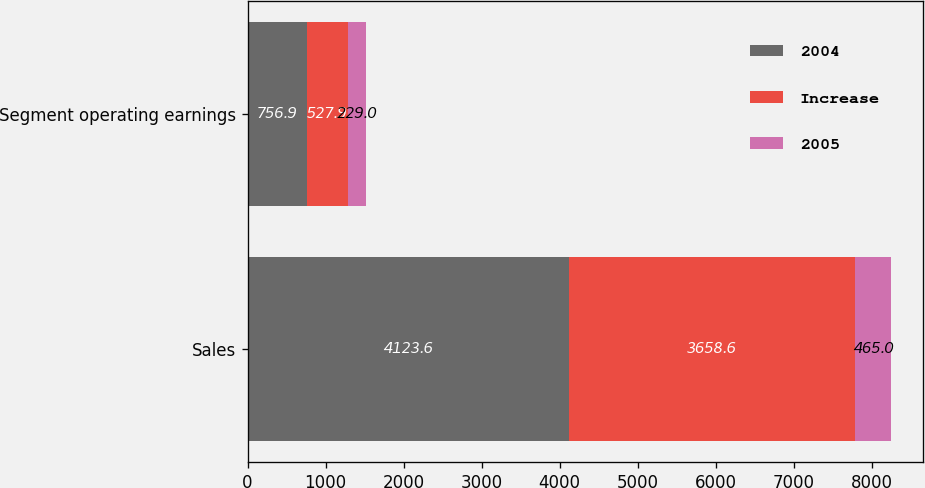Convert chart. <chart><loc_0><loc_0><loc_500><loc_500><stacked_bar_chart><ecel><fcel>Sales<fcel>Segment operating earnings<nl><fcel>2004<fcel>4123.6<fcel>756.9<nl><fcel>Increase<fcel>3658.6<fcel>527.9<nl><fcel>2005<fcel>465<fcel>229<nl></chart> 